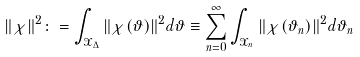<formula> <loc_0><loc_0><loc_500><loc_500>\| \chi \| ^ { 2 } \colon = \int _ { \mathcal { X } _ { \Delta } } \| \chi ( \vartheta ) \| ^ { 2 } d \vartheta \equiv \sum _ { n = 0 } ^ { \infty } \int _ { \mathcal { X } _ { n } } \| \chi ( \vartheta _ { n } ) \| ^ { 2 } d \vartheta _ { n }</formula> 